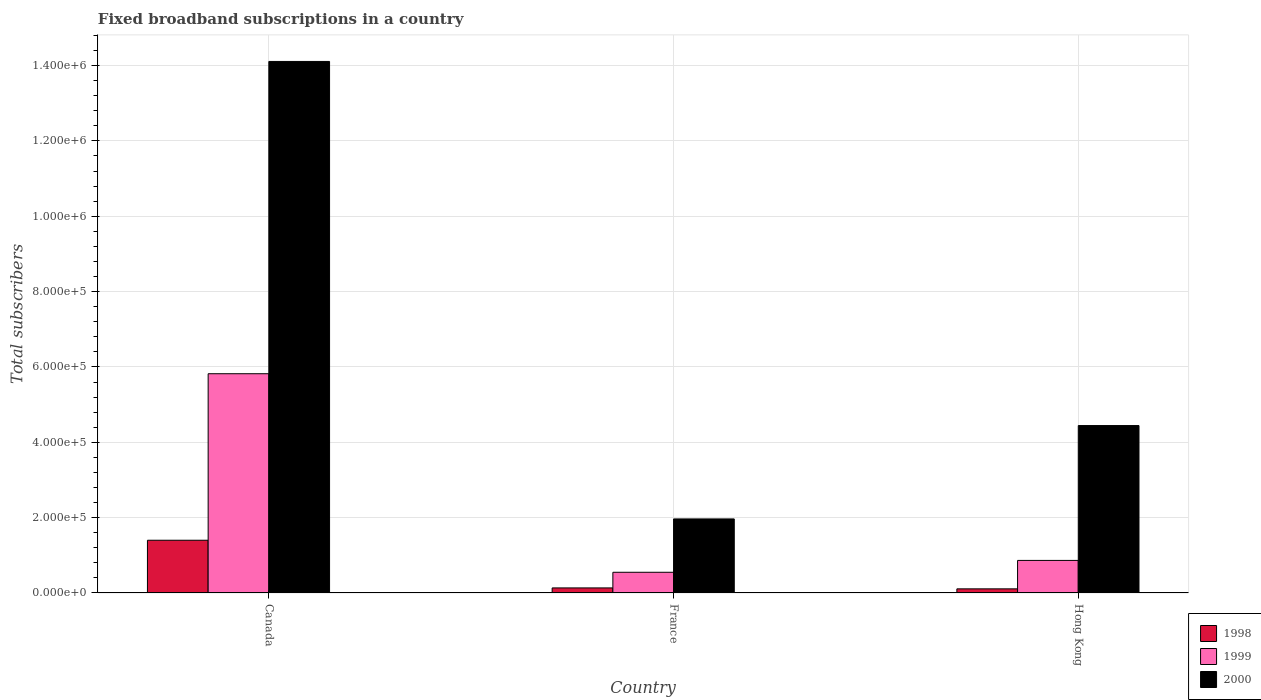How many groups of bars are there?
Ensure brevity in your answer.  3. What is the label of the 3rd group of bars from the left?
Your answer should be compact. Hong Kong. What is the number of broadband subscriptions in 2000 in Hong Kong?
Ensure brevity in your answer.  4.44e+05. Across all countries, what is the maximum number of broadband subscriptions in 2000?
Provide a succinct answer. 1.41e+06. Across all countries, what is the minimum number of broadband subscriptions in 2000?
Provide a succinct answer. 1.97e+05. In which country was the number of broadband subscriptions in 1998 minimum?
Provide a short and direct response. Hong Kong. What is the total number of broadband subscriptions in 1998 in the graph?
Give a very brief answer. 1.64e+05. What is the difference between the number of broadband subscriptions in 1998 in Canada and that in France?
Provide a succinct answer. 1.27e+05. What is the difference between the number of broadband subscriptions in 1999 in Hong Kong and the number of broadband subscriptions in 1998 in Canada?
Provide a short and direct response. -5.35e+04. What is the average number of broadband subscriptions in 2000 per country?
Your response must be concise. 6.84e+05. What is the difference between the number of broadband subscriptions of/in 1998 and number of broadband subscriptions of/in 2000 in Hong Kong?
Provide a succinct answer. -4.33e+05. What is the ratio of the number of broadband subscriptions in 1998 in Canada to that in Hong Kong?
Provide a succinct answer. 12.73. Is the difference between the number of broadband subscriptions in 1998 in France and Hong Kong greater than the difference between the number of broadband subscriptions in 2000 in France and Hong Kong?
Give a very brief answer. Yes. What is the difference between the highest and the second highest number of broadband subscriptions in 1998?
Your answer should be compact. 1.29e+05. What is the difference between the highest and the lowest number of broadband subscriptions in 1999?
Offer a terse response. 5.27e+05. In how many countries, is the number of broadband subscriptions in 1999 greater than the average number of broadband subscriptions in 1999 taken over all countries?
Offer a very short reply. 1. Is it the case that in every country, the sum of the number of broadband subscriptions in 2000 and number of broadband subscriptions in 1999 is greater than the number of broadband subscriptions in 1998?
Make the answer very short. Yes. How many bars are there?
Provide a succinct answer. 9. What is the difference between two consecutive major ticks on the Y-axis?
Keep it short and to the point. 2.00e+05. Where does the legend appear in the graph?
Your answer should be compact. Bottom right. How are the legend labels stacked?
Make the answer very short. Vertical. What is the title of the graph?
Your response must be concise. Fixed broadband subscriptions in a country. What is the label or title of the Y-axis?
Your answer should be very brief. Total subscribers. What is the Total subscribers of 1999 in Canada?
Provide a succinct answer. 5.82e+05. What is the Total subscribers of 2000 in Canada?
Your answer should be very brief. 1.41e+06. What is the Total subscribers of 1998 in France?
Provide a succinct answer. 1.35e+04. What is the Total subscribers in 1999 in France?
Provide a short and direct response. 5.50e+04. What is the Total subscribers in 2000 in France?
Offer a terse response. 1.97e+05. What is the Total subscribers of 1998 in Hong Kong?
Keep it short and to the point. 1.10e+04. What is the Total subscribers of 1999 in Hong Kong?
Offer a very short reply. 8.65e+04. What is the Total subscribers in 2000 in Hong Kong?
Provide a short and direct response. 4.44e+05. Across all countries, what is the maximum Total subscribers of 1999?
Your answer should be compact. 5.82e+05. Across all countries, what is the maximum Total subscribers in 2000?
Provide a short and direct response. 1.41e+06. Across all countries, what is the minimum Total subscribers of 1998?
Offer a very short reply. 1.10e+04. Across all countries, what is the minimum Total subscribers of 1999?
Provide a short and direct response. 5.50e+04. Across all countries, what is the minimum Total subscribers of 2000?
Offer a terse response. 1.97e+05. What is the total Total subscribers of 1998 in the graph?
Ensure brevity in your answer.  1.64e+05. What is the total Total subscribers of 1999 in the graph?
Offer a terse response. 7.23e+05. What is the total Total subscribers of 2000 in the graph?
Your response must be concise. 2.05e+06. What is the difference between the Total subscribers of 1998 in Canada and that in France?
Provide a succinct answer. 1.27e+05. What is the difference between the Total subscribers in 1999 in Canada and that in France?
Give a very brief answer. 5.27e+05. What is the difference between the Total subscribers in 2000 in Canada and that in France?
Your response must be concise. 1.21e+06. What is the difference between the Total subscribers in 1998 in Canada and that in Hong Kong?
Make the answer very short. 1.29e+05. What is the difference between the Total subscribers in 1999 in Canada and that in Hong Kong?
Provide a succinct answer. 4.96e+05. What is the difference between the Total subscribers of 2000 in Canada and that in Hong Kong?
Give a very brief answer. 9.66e+05. What is the difference between the Total subscribers in 1998 in France and that in Hong Kong?
Make the answer very short. 2464. What is the difference between the Total subscribers of 1999 in France and that in Hong Kong?
Ensure brevity in your answer.  -3.15e+04. What is the difference between the Total subscribers in 2000 in France and that in Hong Kong?
Give a very brief answer. -2.48e+05. What is the difference between the Total subscribers of 1998 in Canada and the Total subscribers of 1999 in France?
Provide a short and direct response. 8.50e+04. What is the difference between the Total subscribers in 1998 in Canada and the Total subscribers in 2000 in France?
Offer a very short reply. -5.66e+04. What is the difference between the Total subscribers in 1999 in Canada and the Total subscribers in 2000 in France?
Your response must be concise. 3.85e+05. What is the difference between the Total subscribers in 1998 in Canada and the Total subscribers in 1999 in Hong Kong?
Your answer should be compact. 5.35e+04. What is the difference between the Total subscribers in 1998 in Canada and the Total subscribers in 2000 in Hong Kong?
Offer a terse response. -3.04e+05. What is the difference between the Total subscribers in 1999 in Canada and the Total subscribers in 2000 in Hong Kong?
Keep it short and to the point. 1.38e+05. What is the difference between the Total subscribers of 1998 in France and the Total subscribers of 1999 in Hong Kong?
Offer a very short reply. -7.30e+04. What is the difference between the Total subscribers of 1998 in France and the Total subscribers of 2000 in Hong Kong?
Offer a very short reply. -4.31e+05. What is the difference between the Total subscribers of 1999 in France and the Total subscribers of 2000 in Hong Kong?
Offer a terse response. -3.89e+05. What is the average Total subscribers of 1998 per country?
Make the answer very short. 5.48e+04. What is the average Total subscribers of 1999 per country?
Provide a succinct answer. 2.41e+05. What is the average Total subscribers in 2000 per country?
Ensure brevity in your answer.  6.84e+05. What is the difference between the Total subscribers of 1998 and Total subscribers of 1999 in Canada?
Keep it short and to the point. -4.42e+05. What is the difference between the Total subscribers in 1998 and Total subscribers in 2000 in Canada?
Make the answer very short. -1.27e+06. What is the difference between the Total subscribers of 1999 and Total subscribers of 2000 in Canada?
Offer a very short reply. -8.29e+05. What is the difference between the Total subscribers in 1998 and Total subscribers in 1999 in France?
Offer a very short reply. -4.15e+04. What is the difference between the Total subscribers of 1998 and Total subscribers of 2000 in France?
Provide a short and direct response. -1.83e+05. What is the difference between the Total subscribers in 1999 and Total subscribers in 2000 in France?
Keep it short and to the point. -1.42e+05. What is the difference between the Total subscribers in 1998 and Total subscribers in 1999 in Hong Kong?
Provide a short and direct response. -7.55e+04. What is the difference between the Total subscribers of 1998 and Total subscribers of 2000 in Hong Kong?
Make the answer very short. -4.33e+05. What is the difference between the Total subscribers in 1999 and Total subscribers in 2000 in Hong Kong?
Provide a succinct answer. -3.58e+05. What is the ratio of the Total subscribers in 1998 in Canada to that in France?
Give a very brief answer. 10.4. What is the ratio of the Total subscribers in 1999 in Canada to that in France?
Keep it short and to the point. 10.58. What is the ratio of the Total subscribers of 2000 in Canada to that in France?
Your answer should be very brief. 7.18. What is the ratio of the Total subscribers of 1998 in Canada to that in Hong Kong?
Offer a very short reply. 12.73. What is the ratio of the Total subscribers in 1999 in Canada to that in Hong Kong?
Offer a very short reply. 6.73. What is the ratio of the Total subscribers in 2000 in Canada to that in Hong Kong?
Keep it short and to the point. 3.17. What is the ratio of the Total subscribers in 1998 in France to that in Hong Kong?
Keep it short and to the point. 1.22. What is the ratio of the Total subscribers in 1999 in France to that in Hong Kong?
Give a very brief answer. 0.64. What is the ratio of the Total subscribers in 2000 in France to that in Hong Kong?
Provide a short and direct response. 0.44. What is the difference between the highest and the second highest Total subscribers in 1998?
Offer a very short reply. 1.27e+05. What is the difference between the highest and the second highest Total subscribers of 1999?
Offer a terse response. 4.96e+05. What is the difference between the highest and the second highest Total subscribers in 2000?
Provide a succinct answer. 9.66e+05. What is the difference between the highest and the lowest Total subscribers of 1998?
Offer a very short reply. 1.29e+05. What is the difference between the highest and the lowest Total subscribers of 1999?
Provide a succinct answer. 5.27e+05. What is the difference between the highest and the lowest Total subscribers of 2000?
Provide a short and direct response. 1.21e+06. 